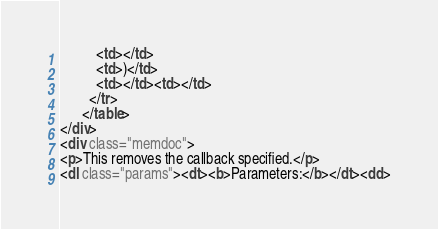<code> <loc_0><loc_0><loc_500><loc_500><_HTML_>          <td></td>
          <td>)</td>
          <td></td><td></td>
        </tr>
      </table>
</div>
<div class="memdoc">
<p>This removes the callback specified.</p>
<dl class="params"><dt><b>Parameters:</b></dt><dd></code> 